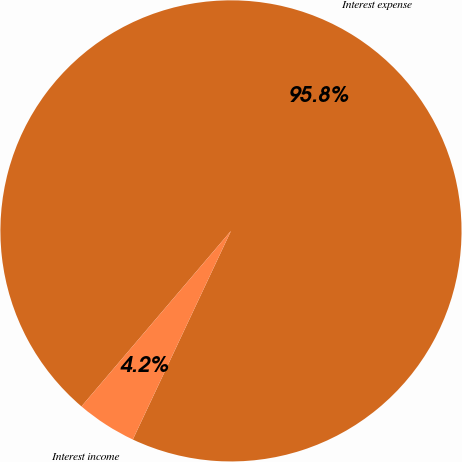Convert chart. <chart><loc_0><loc_0><loc_500><loc_500><pie_chart><fcel>Interest expense<fcel>Interest income<nl><fcel>95.77%<fcel>4.23%<nl></chart> 